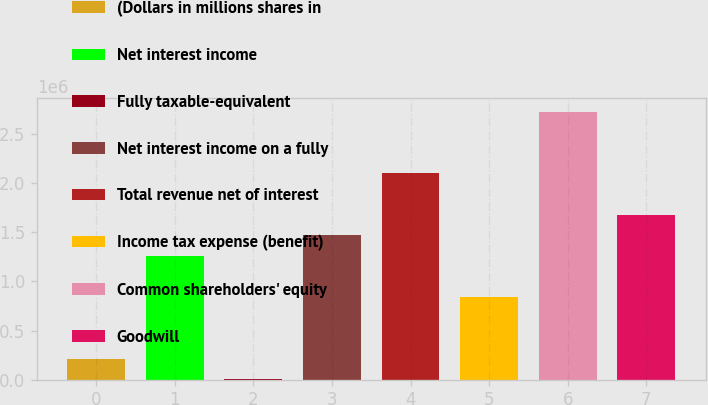Convert chart. <chart><loc_0><loc_0><loc_500><loc_500><bar_chart><fcel>(Dollars in millions shares in<fcel>Net interest income<fcel>Fully taxable-equivalent<fcel>Net interest income on a fully<fcel>Total revenue net of interest<fcel>Income tax expense (benefit)<fcel>Common shareholders' equity<fcel>Goodwill<nl><fcel>210980<fcel>1.26158e+06<fcel>859<fcel>1.4717e+06<fcel>2.10206e+06<fcel>841341<fcel>2.73243e+06<fcel>1.68182e+06<nl></chart> 